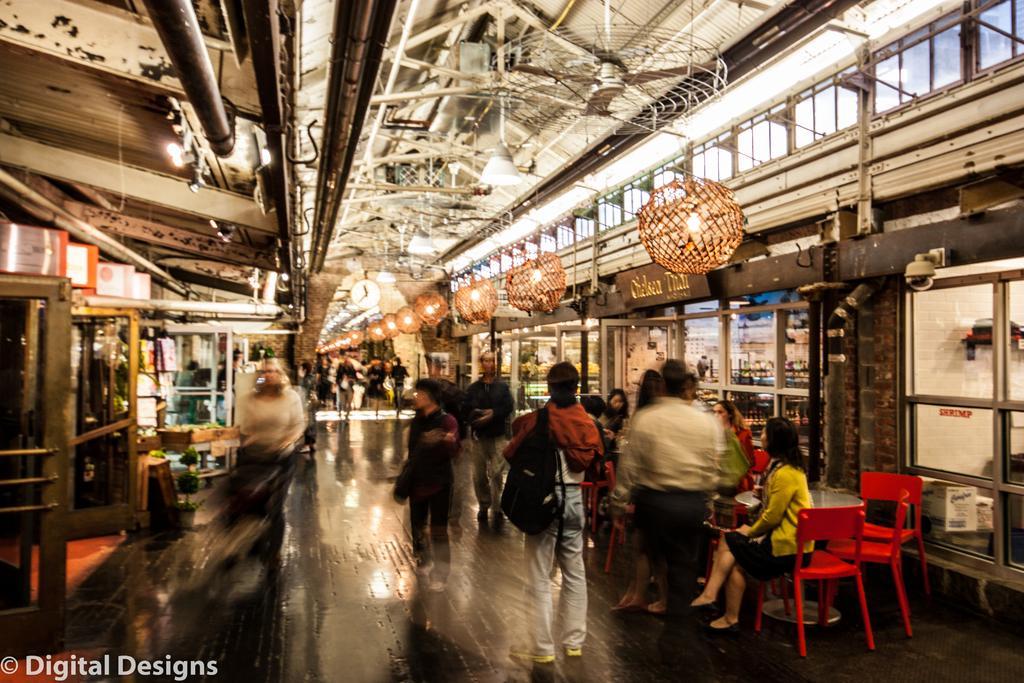Describe this image in one or two sentences. In this picture we can see group of people some are sitting on chair and some are standing and in the background we can see some metal doors and glass doors, poles, lights in decorative lamp and above we have a roof with fans, rods, pipes. 